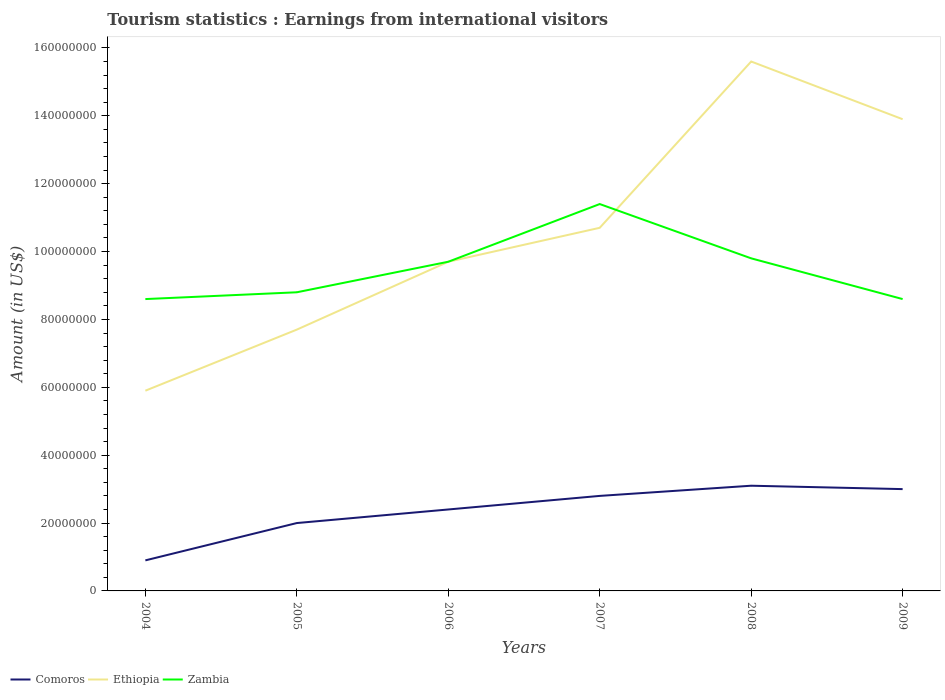How many different coloured lines are there?
Your response must be concise. 3. Across all years, what is the maximum earnings from international visitors in Comoros?
Your response must be concise. 9.00e+06. What is the total earnings from international visitors in Zambia in the graph?
Offer a very short reply. -2.00e+06. What is the difference between the highest and the second highest earnings from international visitors in Zambia?
Keep it short and to the point. 2.80e+07. What is the difference between the highest and the lowest earnings from international visitors in Ethiopia?
Ensure brevity in your answer.  3. Are the values on the major ticks of Y-axis written in scientific E-notation?
Your response must be concise. No. Does the graph contain grids?
Give a very brief answer. No. What is the title of the graph?
Your answer should be compact. Tourism statistics : Earnings from international visitors. Does "East Asia (all income levels)" appear as one of the legend labels in the graph?
Your response must be concise. No. What is the label or title of the Y-axis?
Your answer should be compact. Amount (in US$). What is the Amount (in US$) in Comoros in 2004?
Offer a very short reply. 9.00e+06. What is the Amount (in US$) in Ethiopia in 2004?
Provide a succinct answer. 5.90e+07. What is the Amount (in US$) in Zambia in 2004?
Provide a succinct answer. 8.60e+07. What is the Amount (in US$) in Ethiopia in 2005?
Your response must be concise. 7.70e+07. What is the Amount (in US$) of Zambia in 2005?
Ensure brevity in your answer.  8.80e+07. What is the Amount (in US$) of Comoros in 2006?
Keep it short and to the point. 2.40e+07. What is the Amount (in US$) of Ethiopia in 2006?
Provide a succinct answer. 9.70e+07. What is the Amount (in US$) of Zambia in 2006?
Make the answer very short. 9.70e+07. What is the Amount (in US$) in Comoros in 2007?
Give a very brief answer. 2.80e+07. What is the Amount (in US$) of Ethiopia in 2007?
Ensure brevity in your answer.  1.07e+08. What is the Amount (in US$) in Zambia in 2007?
Offer a terse response. 1.14e+08. What is the Amount (in US$) in Comoros in 2008?
Give a very brief answer. 3.10e+07. What is the Amount (in US$) of Ethiopia in 2008?
Make the answer very short. 1.56e+08. What is the Amount (in US$) in Zambia in 2008?
Your answer should be very brief. 9.80e+07. What is the Amount (in US$) in Comoros in 2009?
Offer a terse response. 3.00e+07. What is the Amount (in US$) of Ethiopia in 2009?
Ensure brevity in your answer.  1.39e+08. What is the Amount (in US$) in Zambia in 2009?
Give a very brief answer. 8.60e+07. Across all years, what is the maximum Amount (in US$) in Comoros?
Your response must be concise. 3.10e+07. Across all years, what is the maximum Amount (in US$) of Ethiopia?
Keep it short and to the point. 1.56e+08. Across all years, what is the maximum Amount (in US$) of Zambia?
Provide a succinct answer. 1.14e+08. Across all years, what is the minimum Amount (in US$) of Comoros?
Keep it short and to the point. 9.00e+06. Across all years, what is the minimum Amount (in US$) of Ethiopia?
Make the answer very short. 5.90e+07. Across all years, what is the minimum Amount (in US$) in Zambia?
Your answer should be very brief. 8.60e+07. What is the total Amount (in US$) in Comoros in the graph?
Provide a short and direct response. 1.42e+08. What is the total Amount (in US$) in Ethiopia in the graph?
Your response must be concise. 6.35e+08. What is the total Amount (in US$) of Zambia in the graph?
Provide a short and direct response. 5.69e+08. What is the difference between the Amount (in US$) of Comoros in 2004 and that in 2005?
Your answer should be very brief. -1.10e+07. What is the difference between the Amount (in US$) in Ethiopia in 2004 and that in 2005?
Provide a short and direct response. -1.80e+07. What is the difference between the Amount (in US$) in Comoros in 2004 and that in 2006?
Your answer should be very brief. -1.50e+07. What is the difference between the Amount (in US$) in Ethiopia in 2004 and that in 2006?
Offer a terse response. -3.80e+07. What is the difference between the Amount (in US$) of Zambia in 2004 and that in 2006?
Offer a very short reply. -1.10e+07. What is the difference between the Amount (in US$) in Comoros in 2004 and that in 2007?
Your response must be concise. -1.90e+07. What is the difference between the Amount (in US$) of Ethiopia in 2004 and that in 2007?
Ensure brevity in your answer.  -4.80e+07. What is the difference between the Amount (in US$) of Zambia in 2004 and that in 2007?
Make the answer very short. -2.80e+07. What is the difference between the Amount (in US$) of Comoros in 2004 and that in 2008?
Make the answer very short. -2.20e+07. What is the difference between the Amount (in US$) in Ethiopia in 2004 and that in 2008?
Your answer should be compact. -9.70e+07. What is the difference between the Amount (in US$) of Zambia in 2004 and that in 2008?
Keep it short and to the point. -1.20e+07. What is the difference between the Amount (in US$) in Comoros in 2004 and that in 2009?
Your answer should be very brief. -2.10e+07. What is the difference between the Amount (in US$) in Ethiopia in 2004 and that in 2009?
Offer a very short reply. -8.00e+07. What is the difference between the Amount (in US$) of Comoros in 2005 and that in 2006?
Offer a very short reply. -4.00e+06. What is the difference between the Amount (in US$) in Ethiopia in 2005 and that in 2006?
Ensure brevity in your answer.  -2.00e+07. What is the difference between the Amount (in US$) of Zambia in 2005 and that in 2006?
Provide a succinct answer. -9.00e+06. What is the difference between the Amount (in US$) in Comoros in 2005 and that in 2007?
Offer a very short reply. -8.00e+06. What is the difference between the Amount (in US$) in Ethiopia in 2005 and that in 2007?
Ensure brevity in your answer.  -3.00e+07. What is the difference between the Amount (in US$) of Zambia in 2005 and that in 2007?
Give a very brief answer. -2.60e+07. What is the difference between the Amount (in US$) of Comoros in 2005 and that in 2008?
Provide a short and direct response. -1.10e+07. What is the difference between the Amount (in US$) of Ethiopia in 2005 and that in 2008?
Offer a very short reply. -7.90e+07. What is the difference between the Amount (in US$) in Zambia in 2005 and that in 2008?
Offer a very short reply. -1.00e+07. What is the difference between the Amount (in US$) of Comoros in 2005 and that in 2009?
Your answer should be very brief. -1.00e+07. What is the difference between the Amount (in US$) in Ethiopia in 2005 and that in 2009?
Provide a short and direct response. -6.20e+07. What is the difference between the Amount (in US$) in Ethiopia in 2006 and that in 2007?
Provide a short and direct response. -1.00e+07. What is the difference between the Amount (in US$) in Zambia in 2006 and that in 2007?
Provide a short and direct response. -1.70e+07. What is the difference between the Amount (in US$) of Comoros in 2006 and that in 2008?
Your answer should be compact. -7.00e+06. What is the difference between the Amount (in US$) of Ethiopia in 2006 and that in 2008?
Provide a succinct answer. -5.90e+07. What is the difference between the Amount (in US$) in Comoros in 2006 and that in 2009?
Provide a short and direct response. -6.00e+06. What is the difference between the Amount (in US$) in Ethiopia in 2006 and that in 2009?
Your answer should be very brief. -4.20e+07. What is the difference between the Amount (in US$) of Zambia in 2006 and that in 2009?
Offer a very short reply. 1.10e+07. What is the difference between the Amount (in US$) in Comoros in 2007 and that in 2008?
Provide a short and direct response. -3.00e+06. What is the difference between the Amount (in US$) of Ethiopia in 2007 and that in 2008?
Make the answer very short. -4.90e+07. What is the difference between the Amount (in US$) in Zambia in 2007 and that in 2008?
Your answer should be very brief. 1.60e+07. What is the difference between the Amount (in US$) in Ethiopia in 2007 and that in 2009?
Provide a succinct answer. -3.20e+07. What is the difference between the Amount (in US$) in Zambia in 2007 and that in 2009?
Offer a very short reply. 2.80e+07. What is the difference between the Amount (in US$) of Comoros in 2008 and that in 2009?
Provide a succinct answer. 1.00e+06. What is the difference between the Amount (in US$) in Ethiopia in 2008 and that in 2009?
Ensure brevity in your answer.  1.70e+07. What is the difference between the Amount (in US$) of Comoros in 2004 and the Amount (in US$) of Ethiopia in 2005?
Keep it short and to the point. -6.80e+07. What is the difference between the Amount (in US$) in Comoros in 2004 and the Amount (in US$) in Zambia in 2005?
Provide a short and direct response. -7.90e+07. What is the difference between the Amount (in US$) in Ethiopia in 2004 and the Amount (in US$) in Zambia in 2005?
Keep it short and to the point. -2.90e+07. What is the difference between the Amount (in US$) in Comoros in 2004 and the Amount (in US$) in Ethiopia in 2006?
Offer a very short reply. -8.80e+07. What is the difference between the Amount (in US$) of Comoros in 2004 and the Amount (in US$) of Zambia in 2006?
Provide a succinct answer. -8.80e+07. What is the difference between the Amount (in US$) in Ethiopia in 2004 and the Amount (in US$) in Zambia in 2006?
Your answer should be very brief. -3.80e+07. What is the difference between the Amount (in US$) in Comoros in 2004 and the Amount (in US$) in Ethiopia in 2007?
Ensure brevity in your answer.  -9.80e+07. What is the difference between the Amount (in US$) of Comoros in 2004 and the Amount (in US$) of Zambia in 2007?
Ensure brevity in your answer.  -1.05e+08. What is the difference between the Amount (in US$) of Ethiopia in 2004 and the Amount (in US$) of Zambia in 2007?
Your answer should be compact. -5.50e+07. What is the difference between the Amount (in US$) in Comoros in 2004 and the Amount (in US$) in Ethiopia in 2008?
Give a very brief answer. -1.47e+08. What is the difference between the Amount (in US$) of Comoros in 2004 and the Amount (in US$) of Zambia in 2008?
Your response must be concise. -8.90e+07. What is the difference between the Amount (in US$) in Ethiopia in 2004 and the Amount (in US$) in Zambia in 2008?
Keep it short and to the point. -3.90e+07. What is the difference between the Amount (in US$) of Comoros in 2004 and the Amount (in US$) of Ethiopia in 2009?
Your response must be concise. -1.30e+08. What is the difference between the Amount (in US$) in Comoros in 2004 and the Amount (in US$) in Zambia in 2009?
Offer a terse response. -7.70e+07. What is the difference between the Amount (in US$) of Ethiopia in 2004 and the Amount (in US$) of Zambia in 2009?
Keep it short and to the point. -2.70e+07. What is the difference between the Amount (in US$) of Comoros in 2005 and the Amount (in US$) of Ethiopia in 2006?
Provide a short and direct response. -7.70e+07. What is the difference between the Amount (in US$) of Comoros in 2005 and the Amount (in US$) of Zambia in 2006?
Provide a succinct answer. -7.70e+07. What is the difference between the Amount (in US$) of Ethiopia in 2005 and the Amount (in US$) of Zambia in 2006?
Your answer should be very brief. -2.00e+07. What is the difference between the Amount (in US$) in Comoros in 2005 and the Amount (in US$) in Ethiopia in 2007?
Make the answer very short. -8.70e+07. What is the difference between the Amount (in US$) of Comoros in 2005 and the Amount (in US$) of Zambia in 2007?
Make the answer very short. -9.40e+07. What is the difference between the Amount (in US$) in Ethiopia in 2005 and the Amount (in US$) in Zambia in 2007?
Provide a short and direct response. -3.70e+07. What is the difference between the Amount (in US$) in Comoros in 2005 and the Amount (in US$) in Ethiopia in 2008?
Your response must be concise. -1.36e+08. What is the difference between the Amount (in US$) in Comoros in 2005 and the Amount (in US$) in Zambia in 2008?
Offer a very short reply. -7.80e+07. What is the difference between the Amount (in US$) of Ethiopia in 2005 and the Amount (in US$) of Zambia in 2008?
Provide a short and direct response. -2.10e+07. What is the difference between the Amount (in US$) in Comoros in 2005 and the Amount (in US$) in Ethiopia in 2009?
Offer a very short reply. -1.19e+08. What is the difference between the Amount (in US$) in Comoros in 2005 and the Amount (in US$) in Zambia in 2009?
Ensure brevity in your answer.  -6.60e+07. What is the difference between the Amount (in US$) of Ethiopia in 2005 and the Amount (in US$) of Zambia in 2009?
Your answer should be compact. -9.00e+06. What is the difference between the Amount (in US$) of Comoros in 2006 and the Amount (in US$) of Ethiopia in 2007?
Your response must be concise. -8.30e+07. What is the difference between the Amount (in US$) in Comoros in 2006 and the Amount (in US$) in Zambia in 2007?
Ensure brevity in your answer.  -9.00e+07. What is the difference between the Amount (in US$) of Ethiopia in 2006 and the Amount (in US$) of Zambia in 2007?
Give a very brief answer. -1.70e+07. What is the difference between the Amount (in US$) of Comoros in 2006 and the Amount (in US$) of Ethiopia in 2008?
Your response must be concise. -1.32e+08. What is the difference between the Amount (in US$) of Comoros in 2006 and the Amount (in US$) of Zambia in 2008?
Your answer should be very brief. -7.40e+07. What is the difference between the Amount (in US$) in Comoros in 2006 and the Amount (in US$) in Ethiopia in 2009?
Your answer should be very brief. -1.15e+08. What is the difference between the Amount (in US$) in Comoros in 2006 and the Amount (in US$) in Zambia in 2009?
Your response must be concise. -6.20e+07. What is the difference between the Amount (in US$) of Ethiopia in 2006 and the Amount (in US$) of Zambia in 2009?
Your answer should be very brief. 1.10e+07. What is the difference between the Amount (in US$) in Comoros in 2007 and the Amount (in US$) in Ethiopia in 2008?
Keep it short and to the point. -1.28e+08. What is the difference between the Amount (in US$) in Comoros in 2007 and the Amount (in US$) in Zambia in 2008?
Your response must be concise. -7.00e+07. What is the difference between the Amount (in US$) in Ethiopia in 2007 and the Amount (in US$) in Zambia in 2008?
Provide a succinct answer. 9.00e+06. What is the difference between the Amount (in US$) in Comoros in 2007 and the Amount (in US$) in Ethiopia in 2009?
Offer a terse response. -1.11e+08. What is the difference between the Amount (in US$) of Comoros in 2007 and the Amount (in US$) of Zambia in 2009?
Provide a short and direct response. -5.80e+07. What is the difference between the Amount (in US$) of Ethiopia in 2007 and the Amount (in US$) of Zambia in 2009?
Your answer should be very brief. 2.10e+07. What is the difference between the Amount (in US$) in Comoros in 2008 and the Amount (in US$) in Ethiopia in 2009?
Make the answer very short. -1.08e+08. What is the difference between the Amount (in US$) of Comoros in 2008 and the Amount (in US$) of Zambia in 2009?
Offer a terse response. -5.50e+07. What is the difference between the Amount (in US$) of Ethiopia in 2008 and the Amount (in US$) of Zambia in 2009?
Offer a terse response. 7.00e+07. What is the average Amount (in US$) in Comoros per year?
Ensure brevity in your answer.  2.37e+07. What is the average Amount (in US$) in Ethiopia per year?
Your response must be concise. 1.06e+08. What is the average Amount (in US$) of Zambia per year?
Provide a succinct answer. 9.48e+07. In the year 2004, what is the difference between the Amount (in US$) of Comoros and Amount (in US$) of Ethiopia?
Provide a short and direct response. -5.00e+07. In the year 2004, what is the difference between the Amount (in US$) in Comoros and Amount (in US$) in Zambia?
Your answer should be compact. -7.70e+07. In the year 2004, what is the difference between the Amount (in US$) of Ethiopia and Amount (in US$) of Zambia?
Keep it short and to the point. -2.70e+07. In the year 2005, what is the difference between the Amount (in US$) in Comoros and Amount (in US$) in Ethiopia?
Ensure brevity in your answer.  -5.70e+07. In the year 2005, what is the difference between the Amount (in US$) in Comoros and Amount (in US$) in Zambia?
Give a very brief answer. -6.80e+07. In the year 2005, what is the difference between the Amount (in US$) of Ethiopia and Amount (in US$) of Zambia?
Keep it short and to the point. -1.10e+07. In the year 2006, what is the difference between the Amount (in US$) of Comoros and Amount (in US$) of Ethiopia?
Provide a short and direct response. -7.30e+07. In the year 2006, what is the difference between the Amount (in US$) in Comoros and Amount (in US$) in Zambia?
Your answer should be very brief. -7.30e+07. In the year 2006, what is the difference between the Amount (in US$) in Ethiopia and Amount (in US$) in Zambia?
Your response must be concise. 0. In the year 2007, what is the difference between the Amount (in US$) in Comoros and Amount (in US$) in Ethiopia?
Your response must be concise. -7.90e+07. In the year 2007, what is the difference between the Amount (in US$) in Comoros and Amount (in US$) in Zambia?
Your response must be concise. -8.60e+07. In the year 2007, what is the difference between the Amount (in US$) of Ethiopia and Amount (in US$) of Zambia?
Offer a terse response. -7.00e+06. In the year 2008, what is the difference between the Amount (in US$) in Comoros and Amount (in US$) in Ethiopia?
Provide a succinct answer. -1.25e+08. In the year 2008, what is the difference between the Amount (in US$) in Comoros and Amount (in US$) in Zambia?
Your answer should be compact. -6.70e+07. In the year 2008, what is the difference between the Amount (in US$) of Ethiopia and Amount (in US$) of Zambia?
Keep it short and to the point. 5.80e+07. In the year 2009, what is the difference between the Amount (in US$) in Comoros and Amount (in US$) in Ethiopia?
Make the answer very short. -1.09e+08. In the year 2009, what is the difference between the Amount (in US$) in Comoros and Amount (in US$) in Zambia?
Your answer should be very brief. -5.60e+07. In the year 2009, what is the difference between the Amount (in US$) in Ethiopia and Amount (in US$) in Zambia?
Provide a succinct answer. 5.30e+07. What is the ratio of the Amount (in US$) of Comoros in 2004 to that in 2005?
Give a very brief answer. 0.45. What is the ratio of the Amount (in US$) in Ethiopia in 2004 to that in 2005?
Your answer should be compact. 0.77. What is the ratio of the Amount (in US$) of Zambia in 2004 to that in 2005?
Ensure brevity in your answer.  0.98. What is the ratio of the Amount (in US$) of Comoros in 2004 to that in 2006?
Your answer should be compact. 0.38. What is the ratio of the Amount (in US$) in Ethiopia in 2004 to that in 2006?
Offer a very short reply. 0.61. What is the ratio of the Amount (in US$) of Zambia in 2004 to that in 2006?
Offer a very short reply. 0.89. What is the ratio of the Amount (in US$) of Comoros in 2004 to that in 2007?
Provide a short and direct response. 0.32. What is the ratio of the Amount (in US$) in Ethiopia in 2004 to that in 2007?
Your answer should be very brief. 0.55. What is the ratio of the Amount (in US$) in Zambia in 2004 to that in 2007?
Your answer should be compact. 0.75. What is the ratio of the Amount (in US$) in Comoros in 2004 to that in 2008?
Offer a very short reply. 0.29. What is the ratio of the Amount (in US$) of Ethiopia in 2004 to that in 2008?
Provide a short and direct response. 0.38. What is the ratio of the Amount (in US$) in Zambia in 2004 to that in 2008?
Your answer should be compact. 0.88. What is the ratio of the Amount (in US$) in Ethiopia in 2004 to that in 2009?
Your answer should be very brief. 0.42. What is the ratio of the Amount (in US$) of Zambia in 2004 to that in 2009?
Provide a succinct answer. 1. What is the ratio of the Amount (in US$) in Comoros in 2005 to that in 2006?
Keep it short and to the point. 0.83. What is the ratio of the Amount (in US$) of Ethiopia in 2005 to that in 2006?
Offer a terse response. 0.79. What is the ratio of the Amount (in US$) of Zambia in 2005 to that in 2006?
Give a very brief answer. 0.91. What is the ratio of the Amount (in US$) in Ethiopia in 2005 to that in 2007?
Your answer should be compact. 0.72. What is the ratio of the Amount (in US$) of Zambia in 2005 to that in 2007?
Give a very brief answer. 0.77. What is the ratio of the Amount (in US$) in Comoros in 2005 to that in 2008?
Ensure brevity in your answer.  0.65. What is the ratio of the Amount (in US$) in Ethiopia in 2005 to that in 2008?
Offer a very short reply. 0.49. What is the ratio of the Amount (in US$) of Zambia in 2005 to that in 2008?
Your answer should be compact. 0.9. What is the ratio of the Amount (in US$) in Comoros in 2005 to that in 2009?
Your answer should be compact. 0.67. What is the ratio of the Amount (in US$) in Ethiopia in 2005 to that in 2009?
Keep it short and to the point. 0.55. What is the ratio of the Amount (in US$) in Zambia in 2005 to that in 2009?
Your answer should be compact. 1.02. What is the ratio of the Amount (in US$) of Comoros in 2006 to that in 2007?
Your answer should be compact. 0.86. What is the ratio of the Amount (in US$) of Ethiopia in 2006 to that in 2007?
Your answer should be very brief. 0.91. What is the ratio of the Amount (in US$) in Zambia in 2006 to that in 2007?
Provide a succinct answer. 0.85. What is the ratio of the Amount (in US$) in Comoros in 2006 to that in 2008?
Keep it short and to the point. 0.77. What is the ratio of the Amount (in US$) of Ethiopia in 2006 to that in 2008?
Your response must be concise. 0.62. What is the ratio of the Amount (in US$) in Zambia in 2006 to that in 2008?
Give a very brief answer. 0.99. What is the ratio of the Amount (in US$) in Comoros in 2006 to that in 2009?
Offer a very short reply. 0.8. What is the ratio of the Amount (in US$) in Ethiopia in 2006 to that in 2009?
Offer a terse response. 0.7. What is the ratio of the Amount (in US$) of Zambia in 2006 to that in 2009?
Make the answer very short. 1.13. What is the ratio of the Amount (in US$) in Comoros in 2007 to that in 2008?
Your response must be concise. 0.9. What is the ratio of the Amount (in US$) of Ethiopia in 2007 to that in 2008?
Offer a terse response. 0.69. What is the ratio of the Amount (in US$) in Zambia in 2007 to that in 2008?
Your response must be concise. 1.16. What is the ratio of the Amount (in US$) in Comoros in 2007 to that in 2009?
Give a very brief answer. 0.93. What is the ratio of the Amount (in US$) of Ethiopia in 2007 to that in 2009?
Make the answer very short. 0.77. What is the ratio of the Amount (in US$) in Zambia in 2007 to that in 2009?
Your answer should be very brief. 1.33. What is the ratio of the Amount (in US$) in Comoros in 2008 to that in 2009?
Your answer should be compact. 1.03. What is the ratio of the Amount (in US$) in Ethiopia in 2008 to that in 2009?
Provide a short and direct response. 1.12. What is the ratio of the Amount (in US$) in Zambia in 2008 to that in 2009?
Ensure brevity in your answer.  1.14. What is the difference between the highest and the second highest Amount (in US$) in Comoros?
Ensure brevity in your answer.  1.00e+06. What is the difference between the highest and the second highest Amount (in US$) of Ethiopia?
Keep it short and to the point. 1.70e+07. What is the difference between the highest and the second highest Amount (in US$) in Zambia?
Offer a very short reply. 1.60e+07. What is the difference between the highest and the lowest Amount (in US$) of Comoros?
Make the answer very short. 2.20e+07. What is the difference between the highest and the lowest Amount (in US$) in Ethiopia?
Ensure brevity in your answer.  9.70e+07. What is the difference between the highest and the lowest Amount (in US$) in Zambia?
Your answer should be very brief. 2.80e+07. 